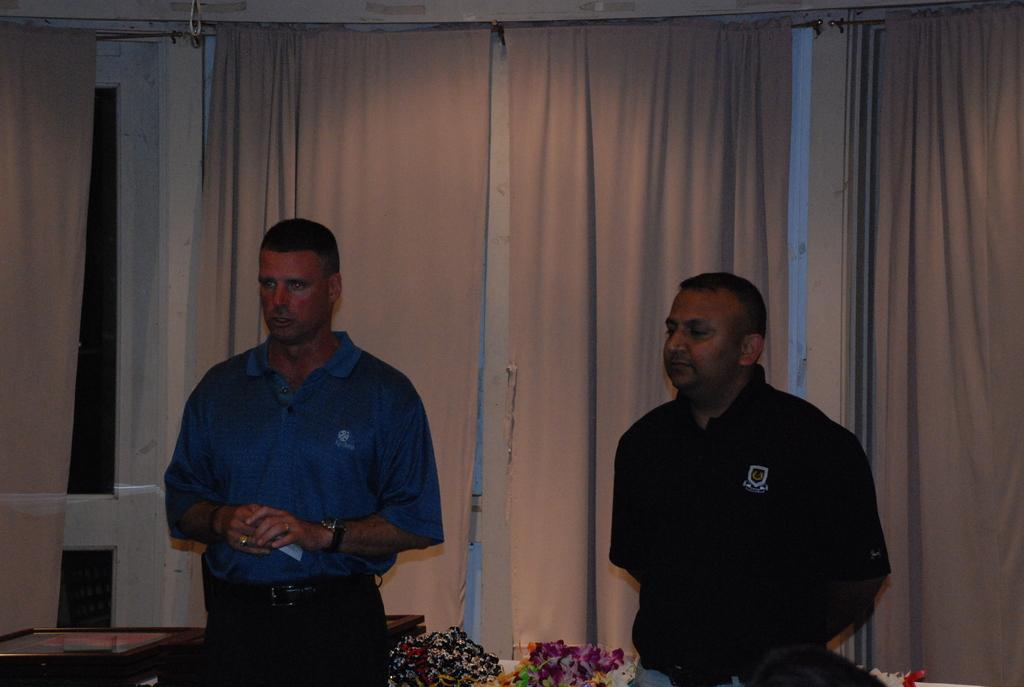How many people are present in the image? There are two persons standing in the image. What can be seen in the background of the image? There is a wall, curtains, and other objects visible in the background of the image. What direction are the persons facing in the image? The provided facts do not mention the direction the persons are facing, so it cannot be determined from the image. What type of card is being used by one of the persons in the image? There is no card present in the image. 